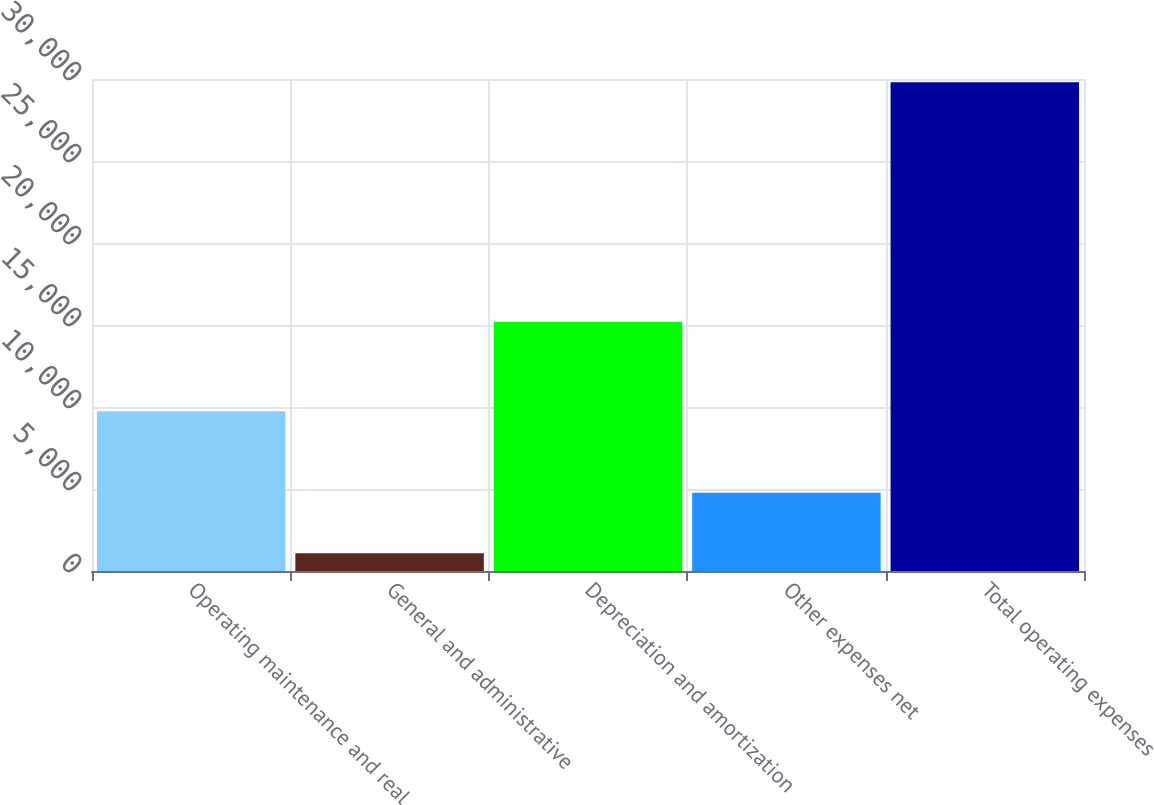<chart> <loc_0><loc_0><loc_500><loc_500><bar_chart><fcel>Operating maintenance and real<fcel>General and administrative<fcel>Depreciation and amortization<fcel>Other expenses net<fcel>Total operating expenses<nl><fcel>9742<fcel>1085<fcel>15204<fcel>4767<fcel>29798<nl></chart> 